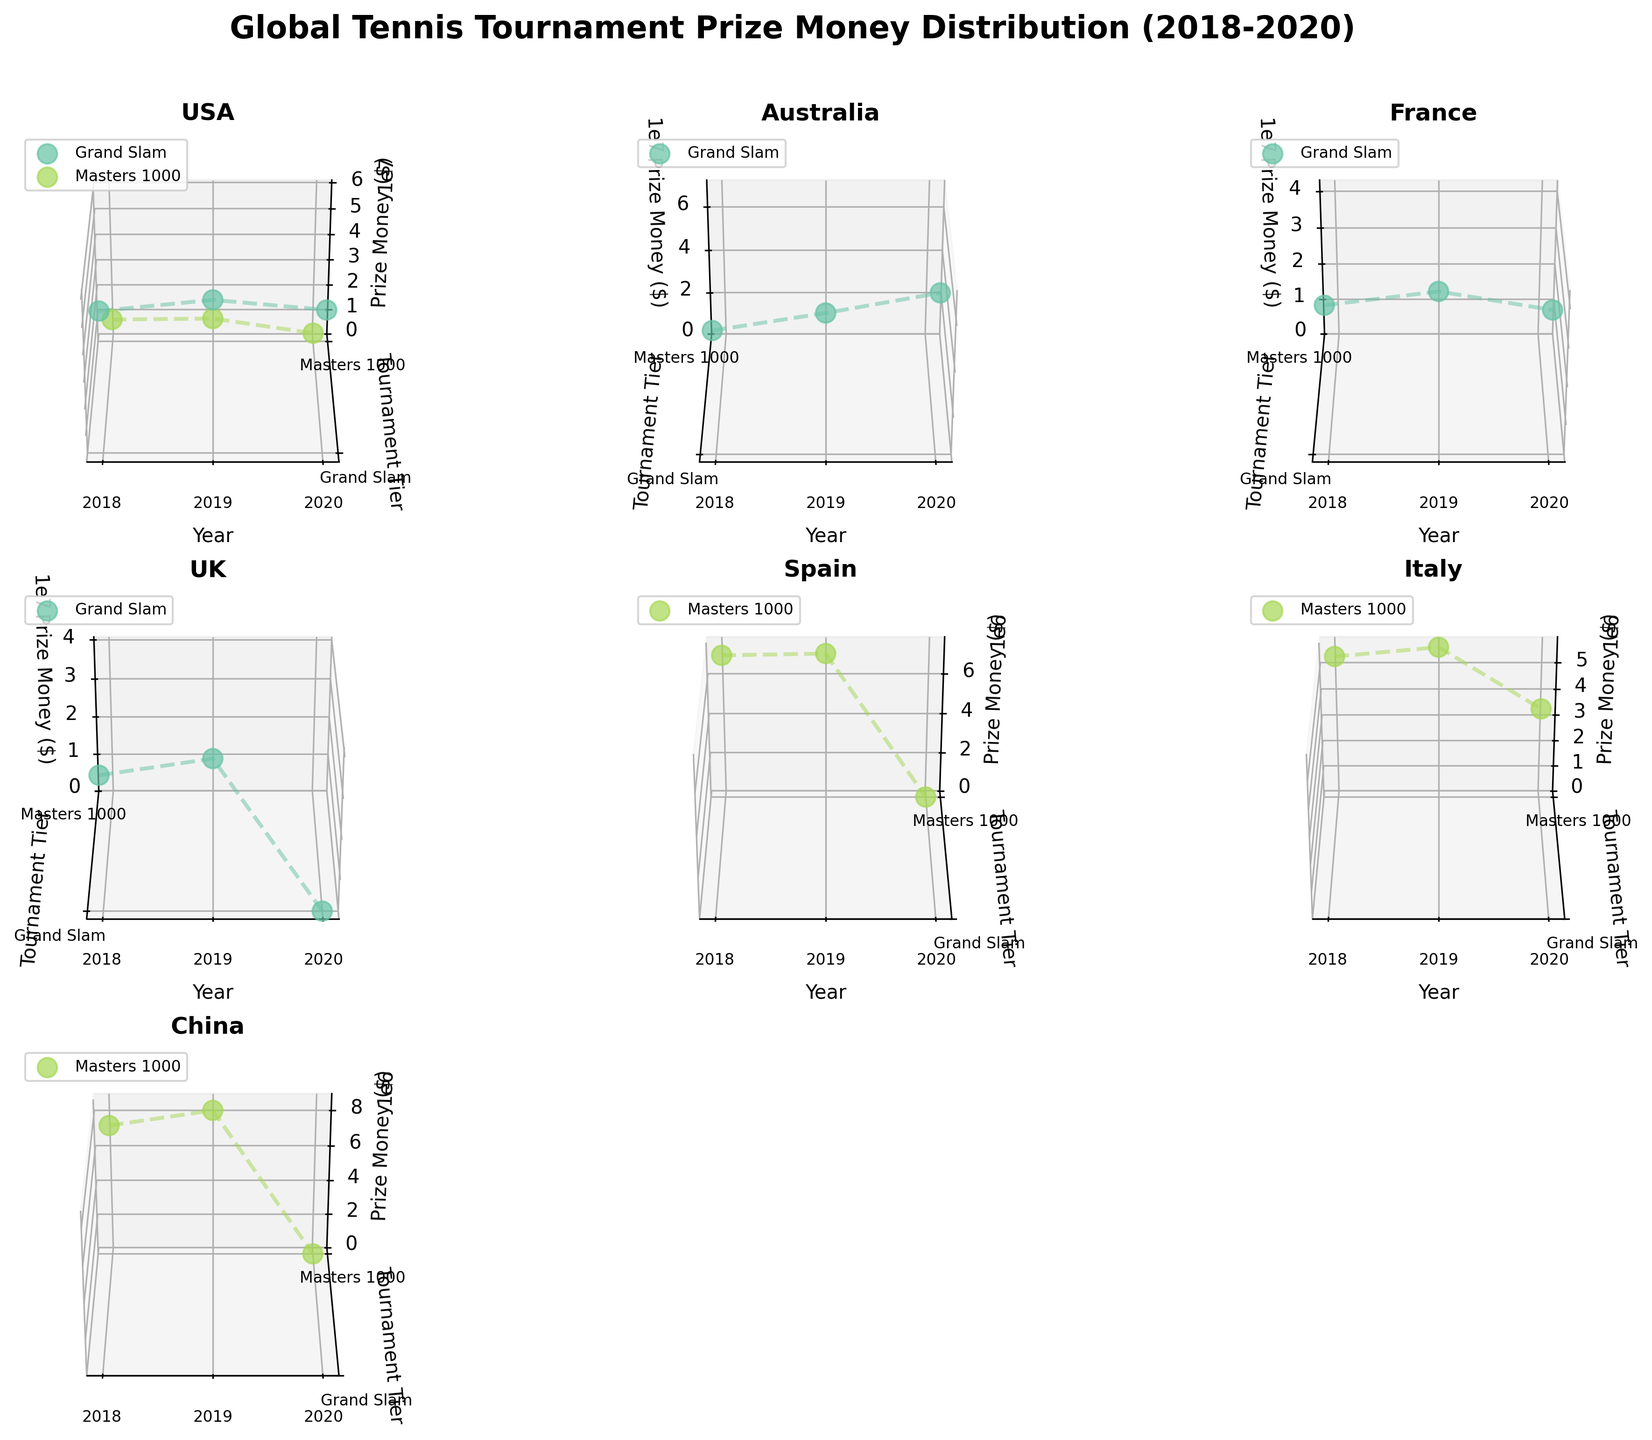Which country shows the highest prize money for Grand Slam tournaments in 2019? From the subplot of each country, we look at the prize money for Grand Slam tournaments in 2019. Australia shows 62,500,000, which is higher than USA (57,000,000), France (42,661,000), and UK (38,000,000).
Answer: Australia Which country had no prize money for a tournament in 2020? Observing each subplot, Spain, UK, and China had zero prize money in 2020 for their respective Masters 1000 tournaments - Madrid Open, Wimbledon, and Shanghai Masters.
Answer: Spain, UK, China How did the prize money difference between the US Open and the Australian Open in 2019? In 2019, the prize money for the US Open was 57,000,000 and Australian Open was 62,500,000. The difference is calculated by subtracting the US Open prize money from the Australian Open prize money: 62,500,000 - 57,000,000 = 5,500,000.
Answer: 5,500,000 Which year saw the highest prize money for the Rome Masters? From the subplot for Italy, we can see the prize money for the Rome Masters increased from 2018 to 2019, but slightly decreased in 2020. The highest was in 2019 with 5,791,280.
Answer: 2019 How does the trend of Grand Slam prize money in France compare to the trend in Australia from 2018 to 2020? In the France subplot, the prize money of Roland Garros increased from 2018 to 2019 and decreased in 2020. In contrast, the Australian Open subplot shows a consistent increase in prize money from 2018 to 2020.
Answer: France shows a peak and drop, Australia shows consistent increase What was the prize money for the Miami Open in 2020 compared to 2019? By comparing the data points for Miami Open in 2019 and 2020 on the USA subplot, the prize money dropped significantly from 9,314,875 in 2019 to 3,343,895 in 2020.
Answer: Decreased significantly What's the average prize money for Grand Slam tournaments in USA over the three years? The prize money data for the US Open (USA) over three years is 53,000,000 (2018), 57,000,000 (2019), and 53,400,000 (2020). The average is calculated as the sum of these amounts divided by 3: (53,000,000 + 57,000,000 + 53,400,000) / 3 = 54,466,667.
Answer: 54,466,667 What pattern can be observed in the prize money of Masters 1000 tournaments in China from 2018 to 2020? The subplot for China shows that the prize money for the Shanghai Masters increased from 2018 to 2019 but dropped to zero in 2020.
Answer: Increased then dropped to zero In which year did France hold the lowest prize money for Roland Garros? The prize money for Roland Garros in France was lowest in 2020 at 38,000,000 compared to 39,197,000 in 2018 and 42,661,000 in 2019.
Answer: 2020 Which country has the most diverse prize money changes across tournament tiers from 2018 to 2020? Looking at the subplots, USA shows significant changes in prize money for both Grand Slam and Masters 1000 tiers with additions and reductions across different tournaments and years.
Answer: USA 